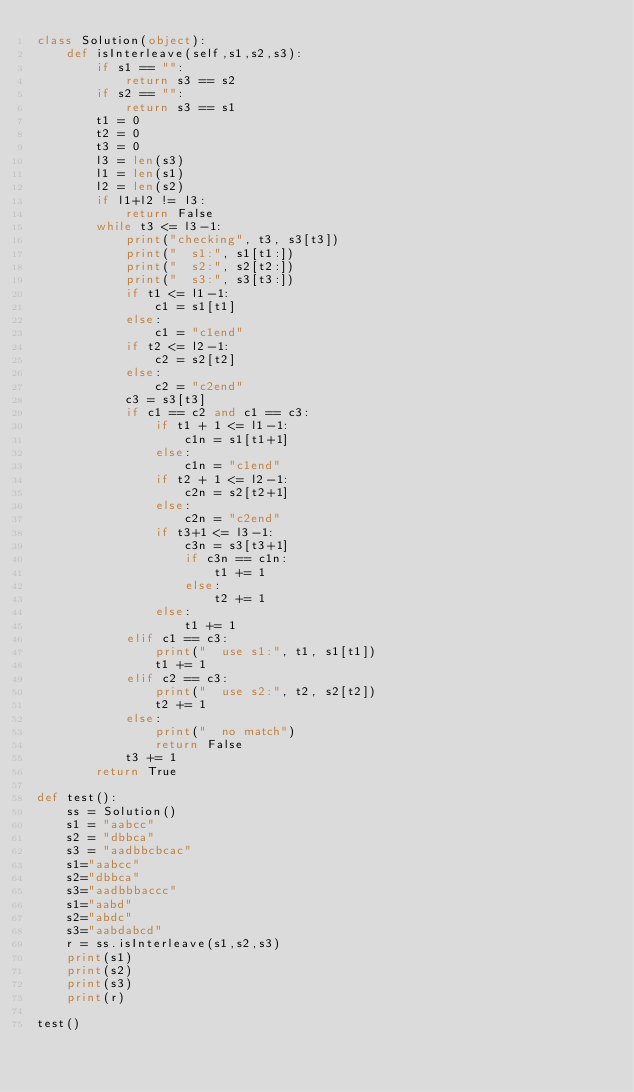Convert code to text. <code><loc_0><loc_0><loc_500><loc_500><_Python_>class Solution(object):
    def isInterleave(self,s1,s2,s3):
        if s1 == "":
            return s3 == s2
        if s2 == "":
            return s3 == s1
        t1 = 0
        t2 = 0
        t3 = 0
        l3 = len(s3)
        l1 = len(s1)
        l2 = len(s2)
        if l1+l2 != l3:
            return False
        while t3 <= l3-1:
            print("checking", t3, s3[t3])
            print("  s1:", s1[t1:])
            print("  s2:", s2[t2:])
            print("  s3:", s3[t3:])
            if t1 <= l1-1:
                c1 = s1[t1]
            else:
                c1 = "c1end"
            if t2 <= l2-1:
                c2 = s2[t2]
            else:
                c2 = "c2end"
            c3 = s3[t3]
            if c1 == c2 and c1 == c3:
                if t1 + 1 <= l1-1:
                    c1n = s1[t1+1]
                else:
                    c1n = "c1end"
                if t2 + 1 <= l2-1:
                    c2n = s2[t2+1]
                else:
                    c2n = "c2end"
                if t3+1 <= l3-1:
                    c3n = s3[t3+1]
                    if c3n == c1n:
                        t1 += 1
                    else:
                        t2 += 1
                else:
                    t1 += 1
            elif c1 == c3:
                print("  use s1:", t1, s1[t1])
                t1 += 1
            elif c2 == c3:
                print("  use s2:", t2, s2[t2])
                t2 += 1
            else:
                print("  no match")
                return False
            t3 += 1
        return True

def test():
    ss = Solution()
    s1 = "aabcc"
    s2 = "dbbca"
    s3 = "aadbbcbcac"
    s1="aabcc"
    s2="dbbca"
    s3="aadbbbaccc"
    s1="aabd"
    s2="abdc"
    s3="aabdabcd"
    r = ss.isInterleave(s1,s2,s3)
    print(s1)
    print(s2)
    print(s3)
    print(r)

test()


</code> 